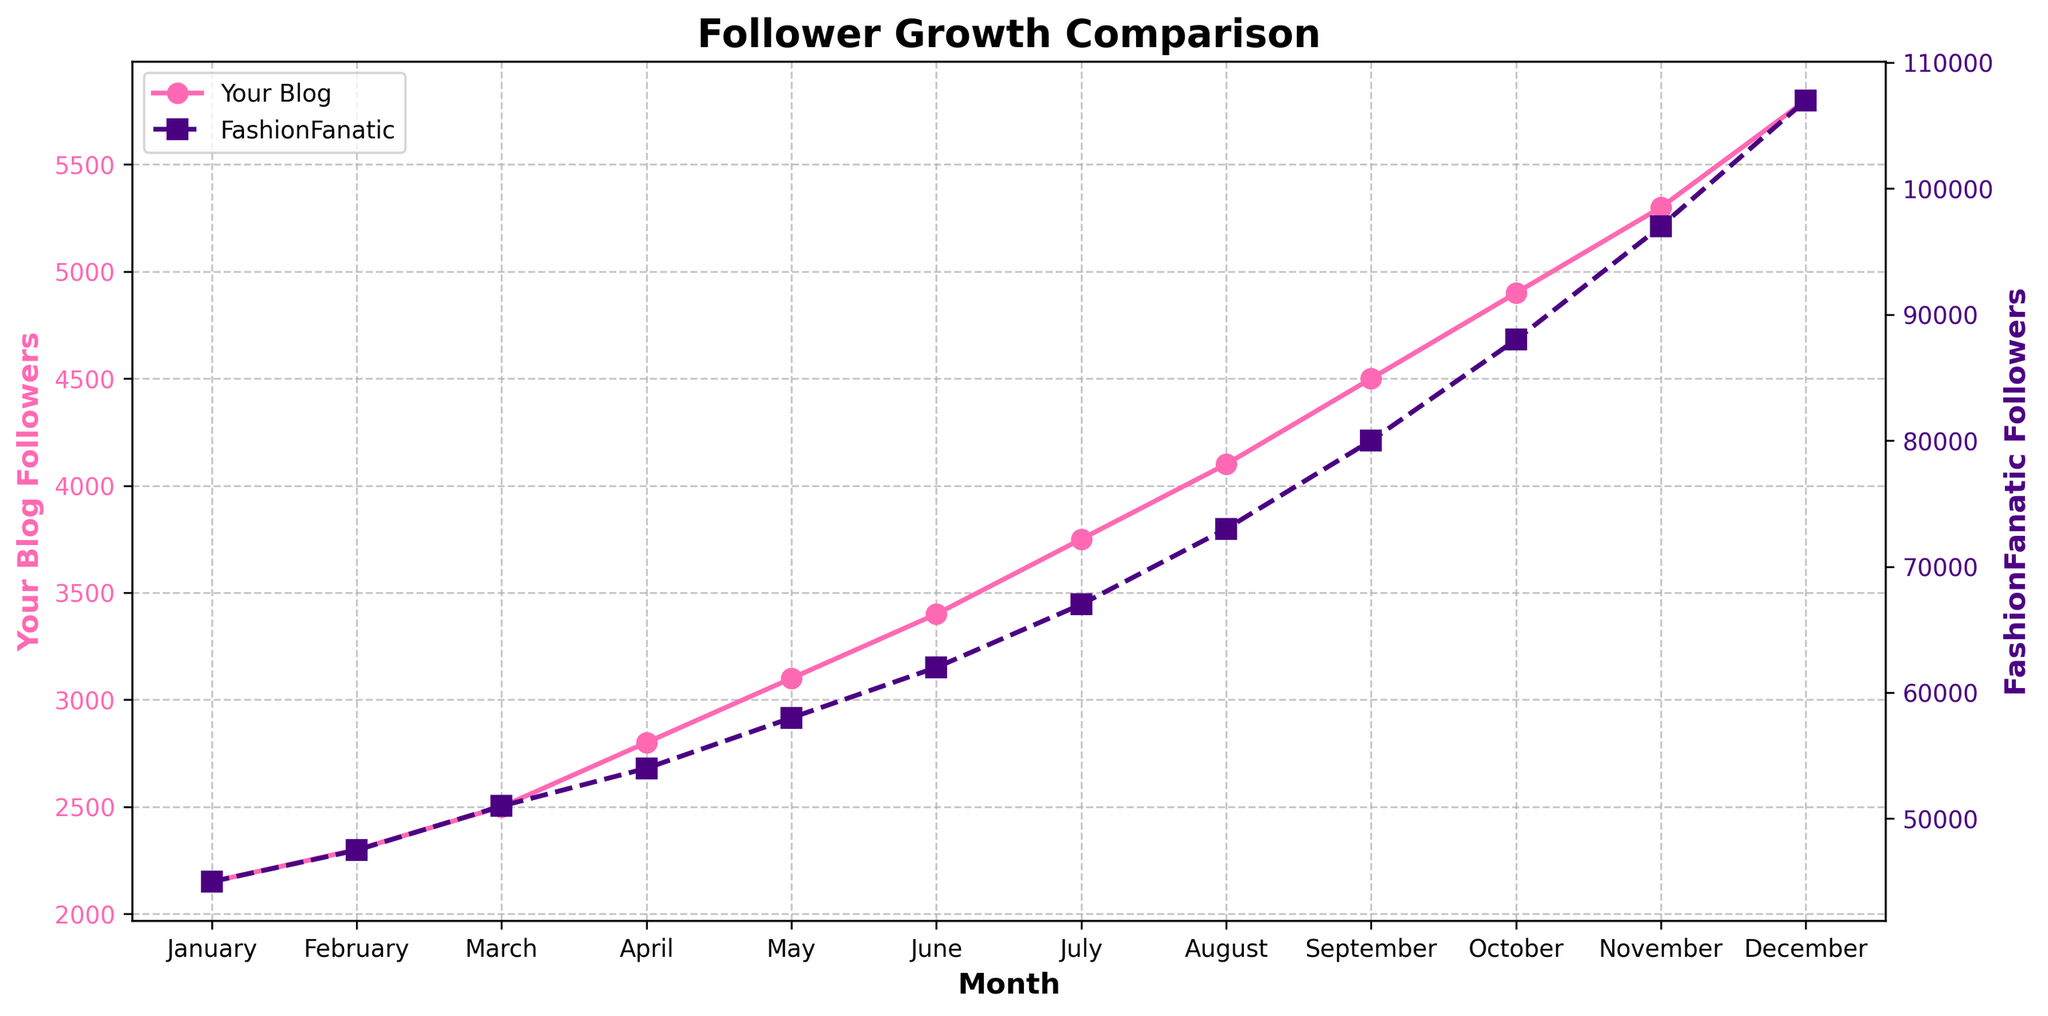What's the total follower growth for your blog from January to December? To find the total follower growth for your blog, take the difference between the followers in December and January: 5800 - 2150.
Answer: 3650 What's the average monthly growth in followers for FashionFanatic? To find the average monthly growth, calculate the total increase over 12 months: (107000 - 45000) / 12.
Answer: 5167 In which month do both blogs show the steepest rise in followers? By examining the visual trendlines, the month with the steepest rise for both blogs can be seen visually where the slope is the steepest. For both blogs, this appears to be between November and December.
Answer: November to December How does the follower growth between April and June compare for both blogs? The follower growth for your blog between April and June is 3400 - 2800, which is 600. For FashionFanatic, it is 62000 - 54000, which is 8000.
Answer: FashionFanatic has a larger growth of 8000 compared to 600 for your blog By how much were your blog's followers fewer than FashionFanatic's in December? Calculate the difference between FashionFanatic’s followers and your blog's followers in December: 107000 - 5800.
Answer: 101200 Are there any months where your blog showed a higher growth rate than FashionFanatic? Calculate the monthly growth rate for each blog and compare. For instance, from January to February: (2300 - 2150) / 2150 and (47500 - 45000) / 45000. Repeat for each month and compare. Visual inspection suggests no months where your blog's growth rate exceeded FashionFanatic's.
Answer: No What visual feature helps to identify the two different blogs' data on the plot? Color and line styles help differentiate the two data sets: your blog is represented by a solid pink line, while FashionFanatic is represented by a dashed purple line.
Answer: Color and line styles Which blog had a higher growth rate in March, and by how much? Calculate the growth rate for March for both blogs: Your blog (2800 - 2300), and FashionFanatic (54000 - 47500). Compare the differences: 2500 - 2000.
Answer: FashionFanatic had a higher growth rate by 2000 followers How much did your blog's followers increase from July to October? Calculate the increase from July (3750) to October (4900): 4900 - 3750.
Answer: 1150 What is the overall trend in followers for both blogs over 12 months? Both blogs show a consistent upward trend in followers, with FashionFanatic having a significantly steeper increase compared to your blog.
Answer: Consistent upward trend 